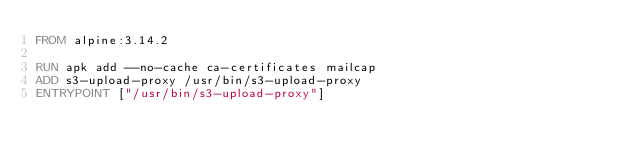Convert code to text. <code><loc_0><loc_0><loc_500><loc_500><_Dockerfile_>FROM alpine:3.14.2

RUN apk add --no-cache ca-certificates mailcap
ADD s3-upload-proxy /usr/bin/s3-upload-proxy
ENTRYPOINT ["/usr/bin/s3-upload-proxy"]
</code> 